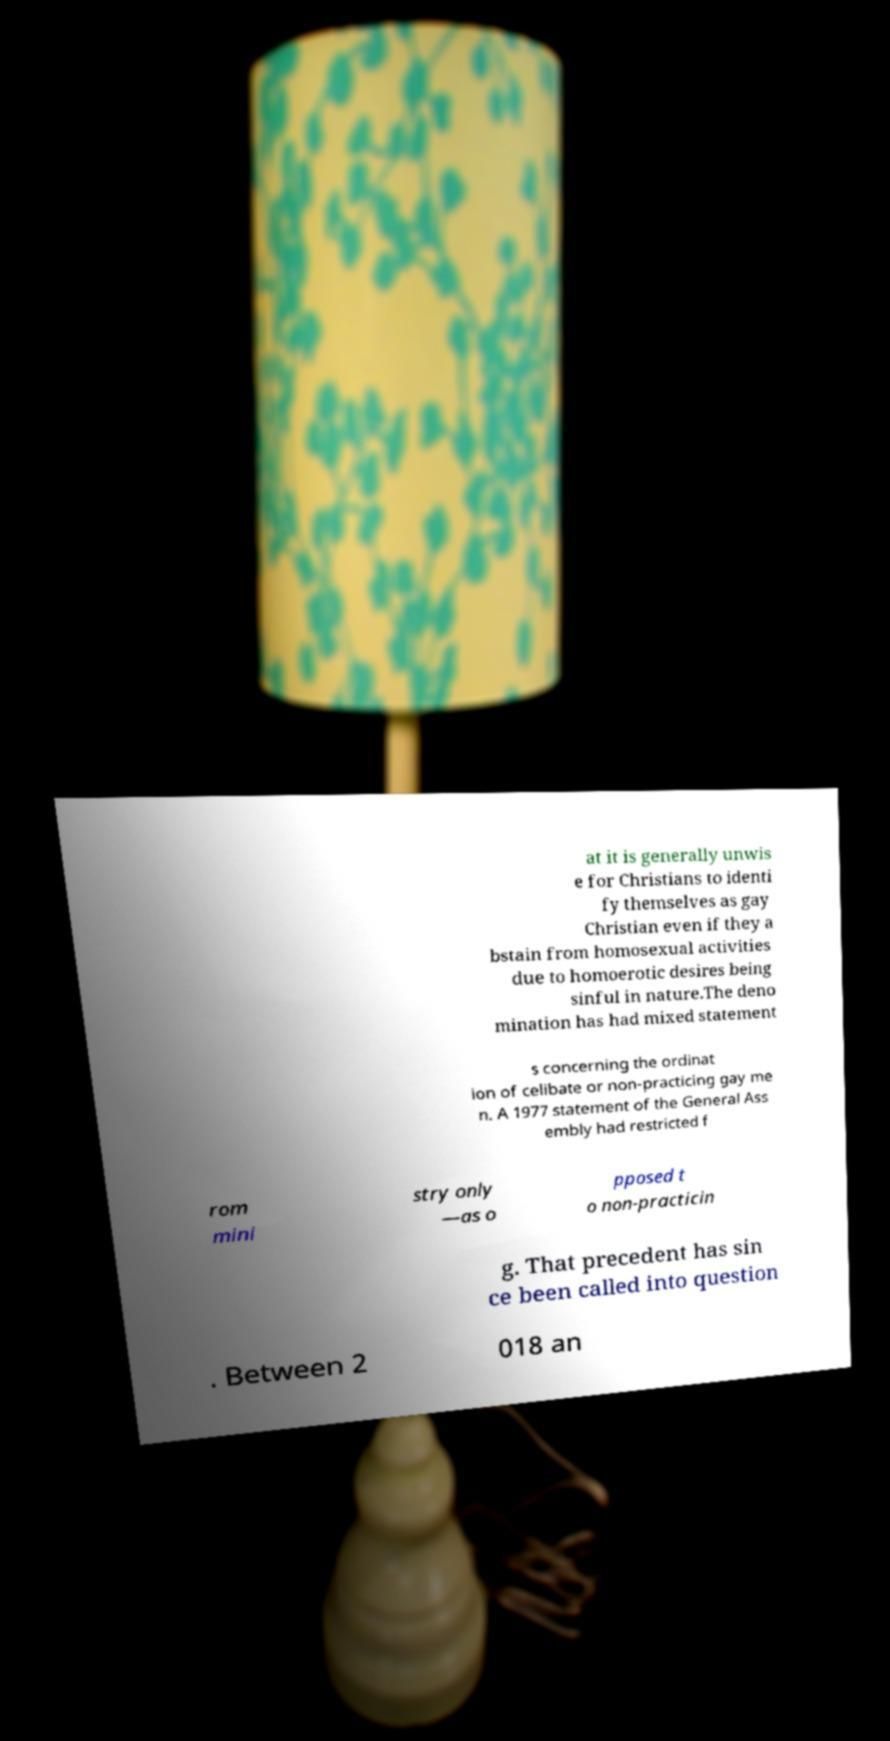Could you assist in decoding the text presented in this image and type it out clearly? at it is generally unwis e for Christians to identi fy themselves as gay Christian even if they a bstain from homosexual activities due to homoerotic desires being sinful in nature.The deno mination has had mixed statement s concerning the ordinat ion of celibate or non-practicing gay me n. A 1977 statement of the General Ass embly had restricted f rom mini stry only —as o pposed t o non-practicin g. That precedent has sin ce been called into question . Between 2 018 an 